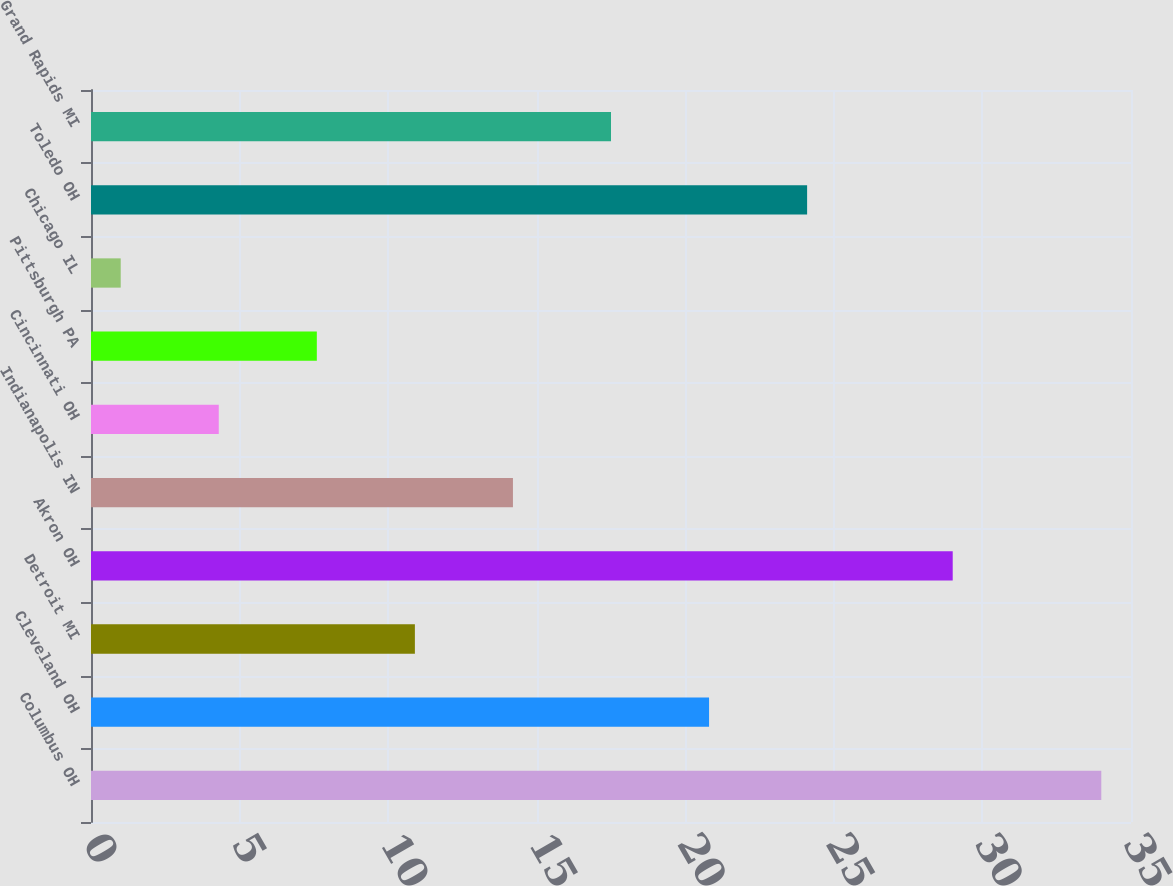Convert chart to OTSL. <chart><loc_0><loc_0><loc_500><loc_500><bar_chart><fcel>Columbus OH<fcel>Cleveland OH<fcel>Detroit MI<fcel>Akron OH<fcel>Indianapolis IN<fcel>Cincinnati OH<fcel>Pittsburgh PA<fcel>Chicago IL<fcel>Toledo OH<fcel>Grand Rapids MI<nl><fcel>34<fcel>20.8<fcel>10.9<fcel>29<fcel>14.2<fcel>4.3<fcel>7.6<fcel>1<fcel>24.1<fcel>17.5<nl></chart> 